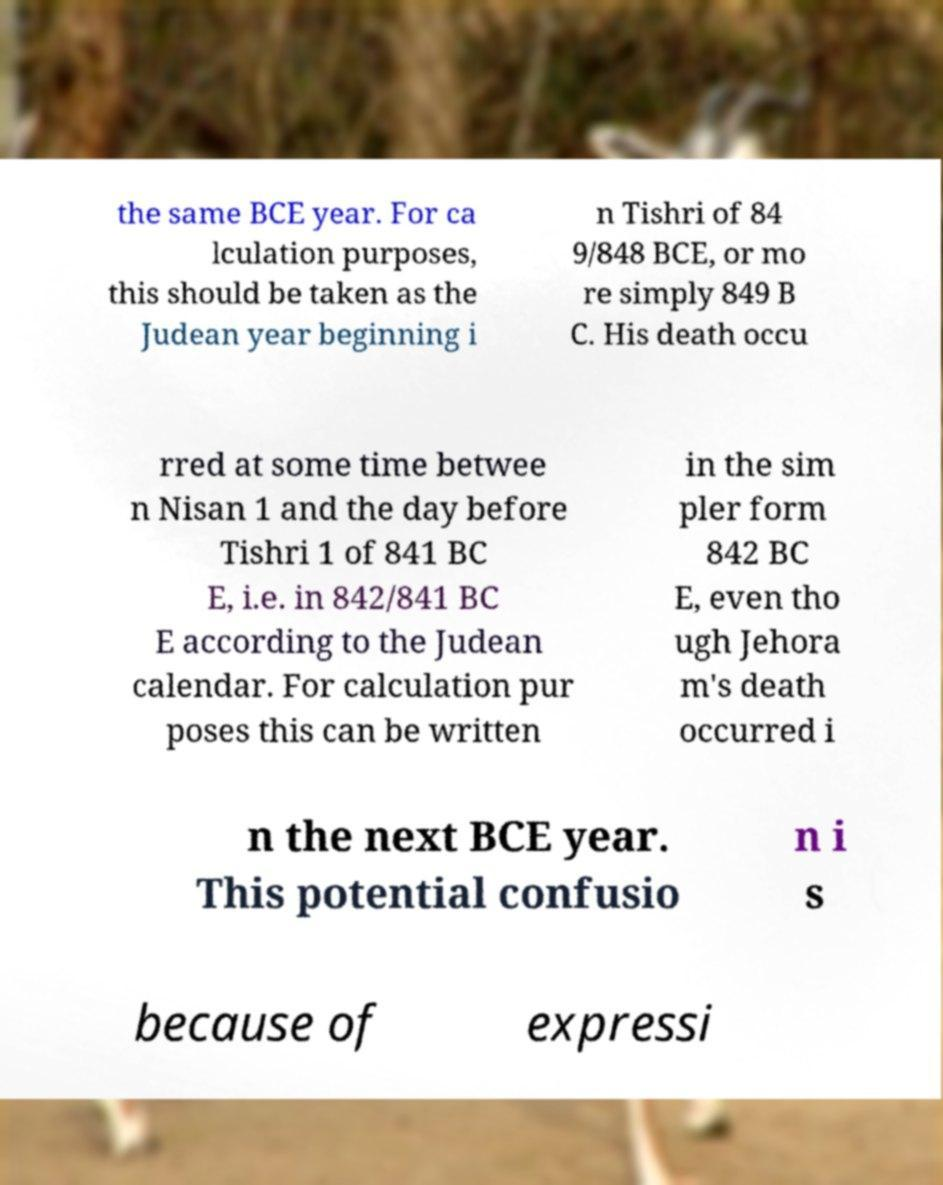What messages or text are displayed in this image? I need them in a readable, typed format. the same BCE year. For ca lculation purposes, this should be taken as the Judean year beginning i n Tishri of 84 9/848 BCE, or mo re simply 849 B C. His death occu rred at some time betwee n Nisan 1 and the day before Tishri 1 of 841 BC E, i.e. in 842/841 BC E according to the Judean calendar. For calculation pur poses this can be written in the sim pler form 842 BC E, even tho ugh Jehora m's death occurred i n the next BCE year. This potential confusio n i s because of expressi 